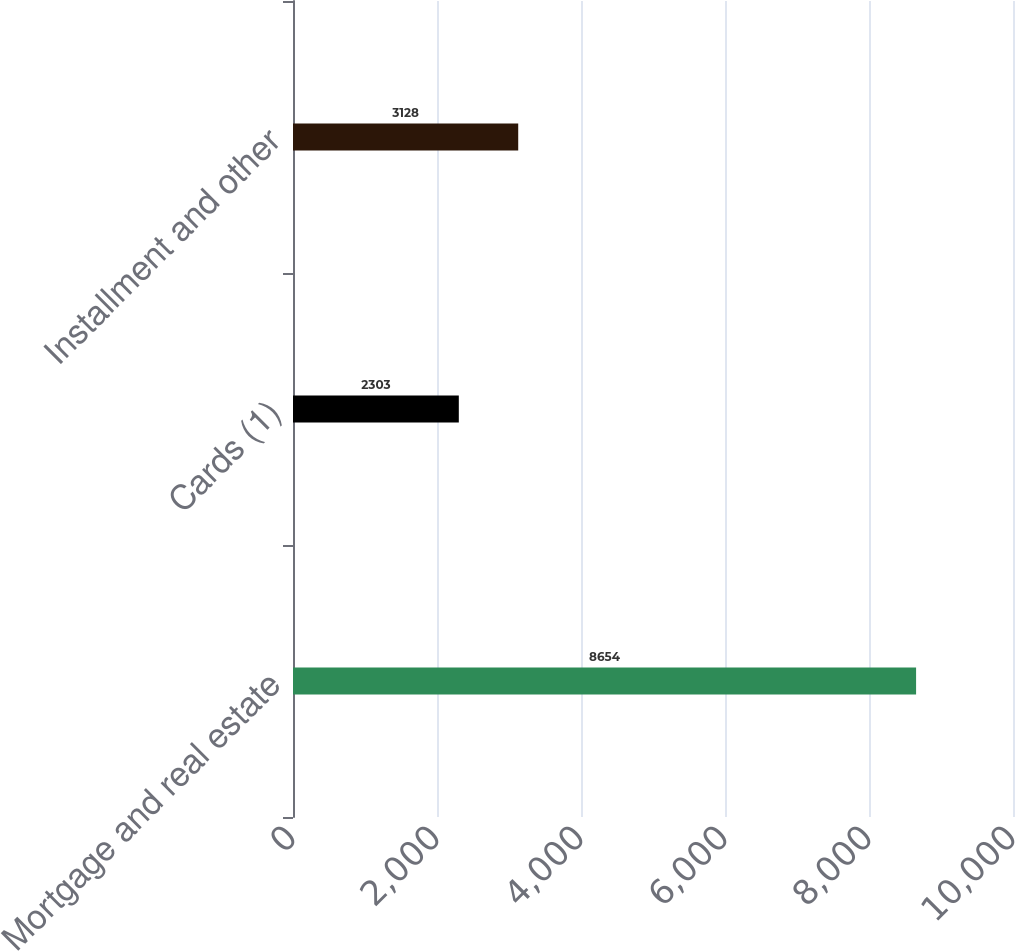Convert chart to OTSL. <chart><loc_0><loc_0><loc_500><loc_500><bar_chart><fcel>Mortgage and real estate<fcel>Cards (1)<fcel>Installment and other<nl><fcel>8654<fcel>2303<fcel>3128<nl></chart> 